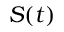<formula> <loc_0><loc_0><loc_500><loc_500>S ( t )</formula> 